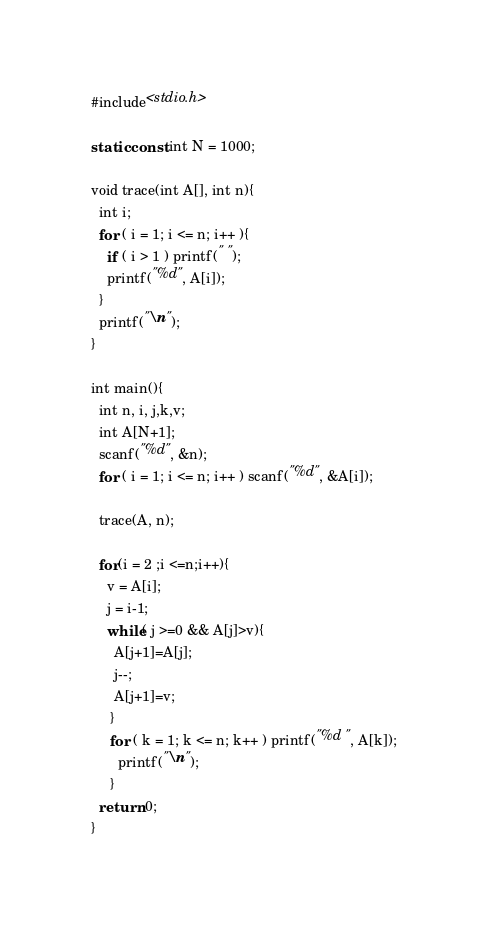Convert code to text. <code><loc_0><loc_0><loc_500><loc_500><_C_>#include<stdio.h>

static const int N = 1000;

void trace(int A[], int n){
  int i;
  for ( i = 1; i <= n; i++ ){
    if ( i > 1 ) printf(" ");
    printf("%d", A[i]);
  }
  printf("\n");
}

int main(){
  int n, i, j,k,v;
  int A[N+1];
  scanf("%d", &n); 
  for ( i = 1; i <= n; i++ ) scanf("%d", &A[i]);

  trace(A, n);

  for(i = 2 ;i <=n;i++){
    v = A[i];
    j = i-1;
    while( j >=0 && A[j]>v){
      A[j+1]=A[j];
      j--;
      A[j+1]=v;
     }
     for ( k = 1; k <= n; k++ ) printf("%d ", A[k]);
       printf("\n");
     }   
  return 0;
}</code> 